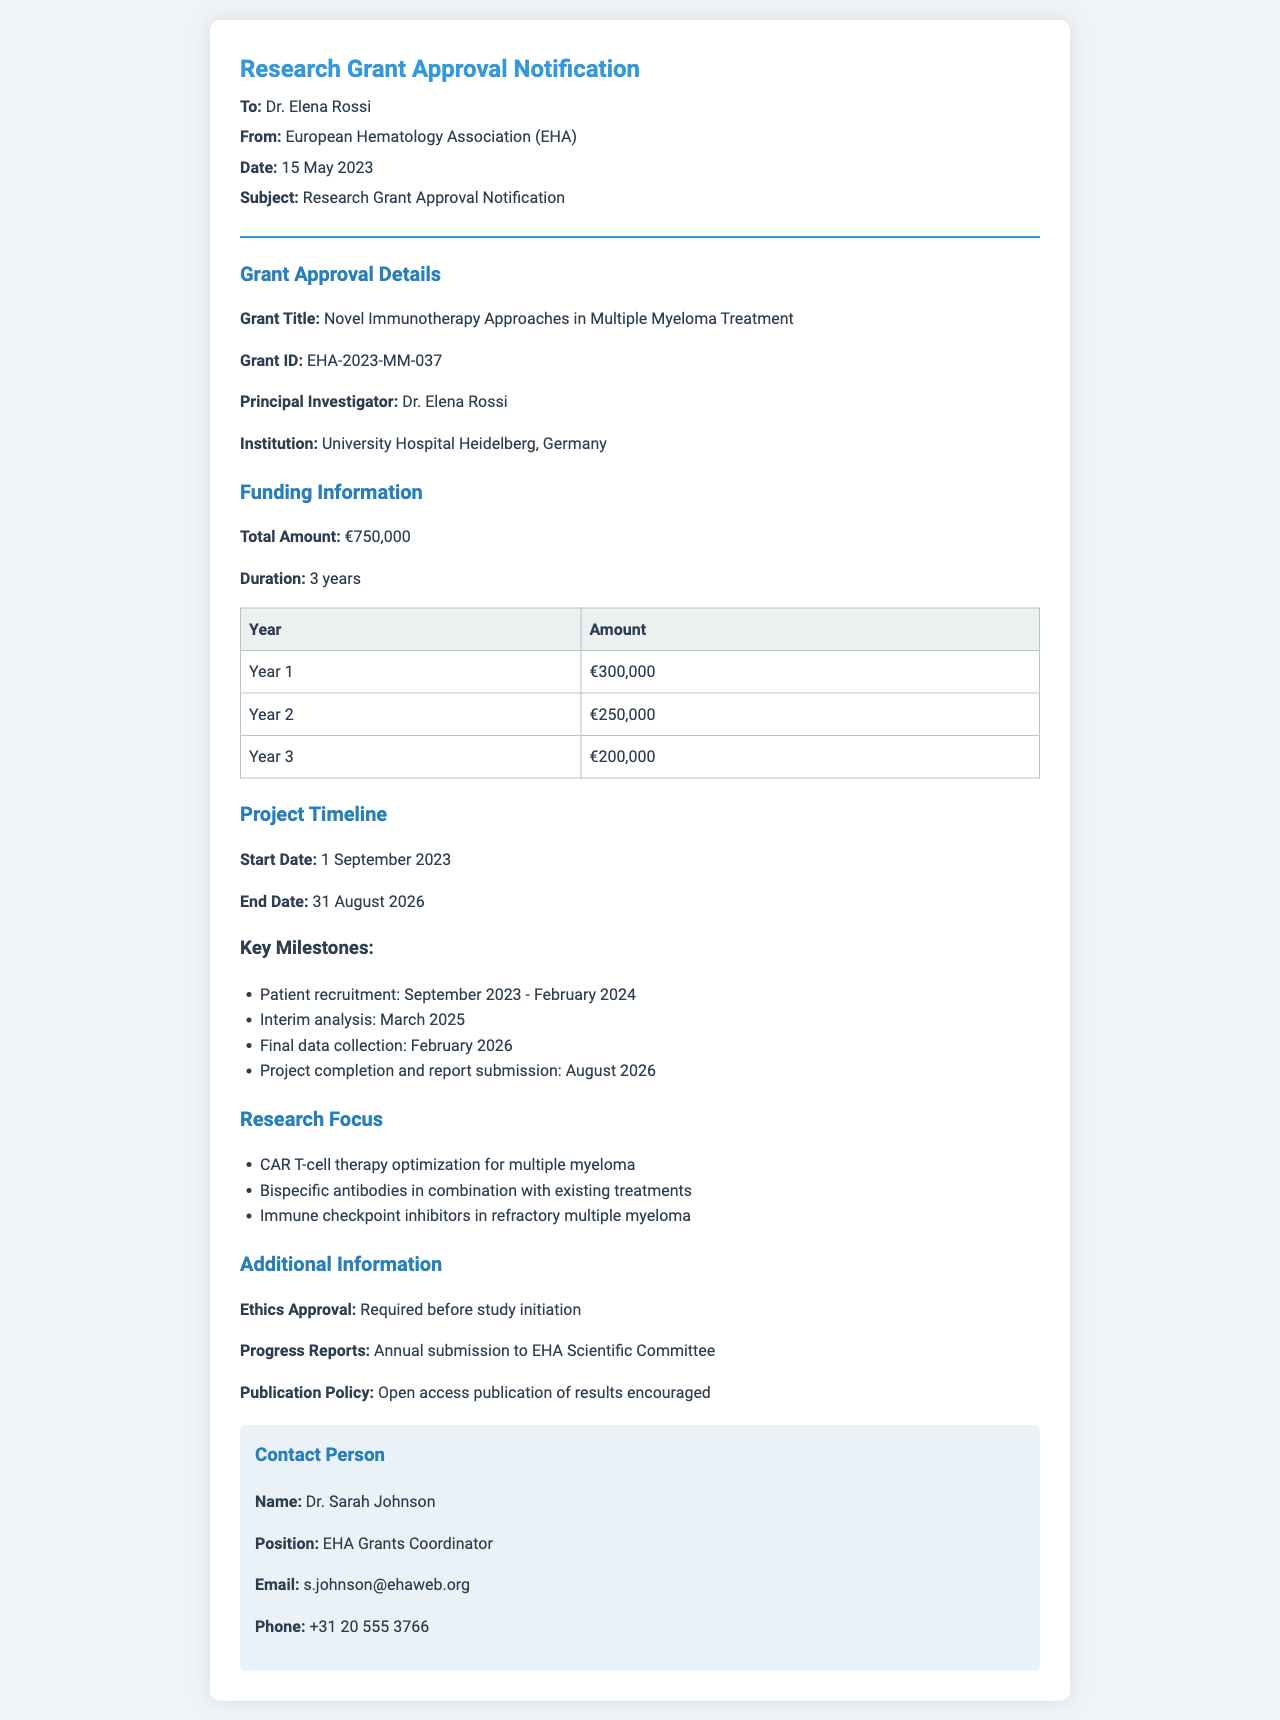What is the grant title? The grant title is the main subject of the research project and is specified in the document under "Grant Title."
Answer: Novel Immunotherapy Approaches in Multiple Myeloma Treatment What is the total funding amount? The total funding amount is mentioned under "Funding Information" in the document.
Answer: €750,000 Who is the principal investigator? The principal investigator is the person leading the research project, identified in the document.
Answer: Dr. Elena Rossi What is the duration of the grant? The duration of the grant is included in the "Funding Information" section, indicating how long the funding will last.
Answer: 3 years When does the project start? The project start date is provided in the "Project Timeline" section as the beginning of the research project.
Answer: 1 September 2023 What is the end date of the project? The end date of the project is outlined in the "Project Timeline" section as when the research is expected to conclude.
Answer: 31 August 2026 How much funding will be allocated in Year 2? The amount allocated for Year 2 is detailed in the funding table, indicating the specific financial resources for that year.
Answer: €250,000 What is required before study initiation? The document mentions what must be obtained prior to starting the study in the "Additional Information" section.
Answer: Ethics Approval Who is the contact person? The contact person provides assistance related to the grant and is described in the "Contact Person" section.
Answer: Dr. Sarah Johnson 